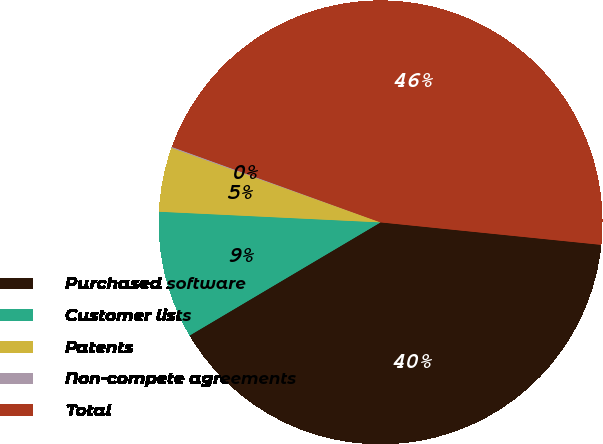Convert chart. <chart><loc_0><loc_0><loc_500><loc_500><pie_chart><fcel>Purchased software<fcel>Customer lists<fcel>Patents<fcel>Non-compete agreements<fcel>Total<nl><fcel>39.87%<fcel>9.28%<fcel>4.68%<fcel>0.08%<fcel>46.09%<nl></chart> 